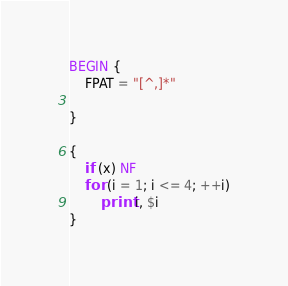Convert code to text. <code><loc_0><loc_0><loc_500><loc_500><_Awk_>BEGIN {
	FPAT = "[^,]*"

}

{
	if (x) NF
	for (i = 1; i <= 4; ++i)
		print i, $i
}
</code> 